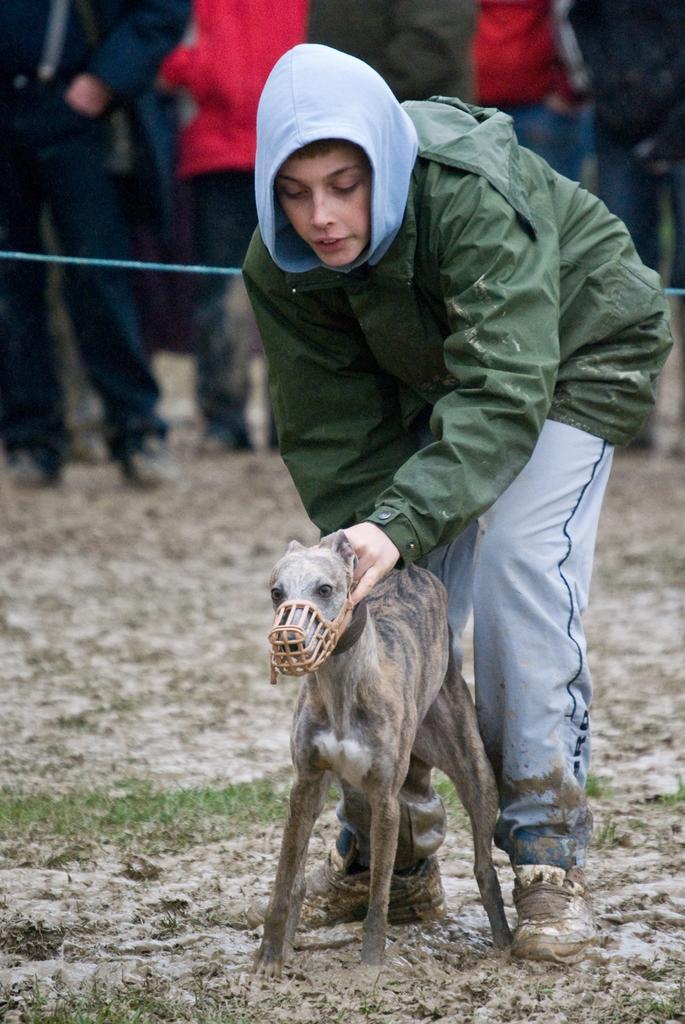Can you describe this image briefly? There is a man wearing a rain jacket catching a dog and there are persons behind him watching them. 